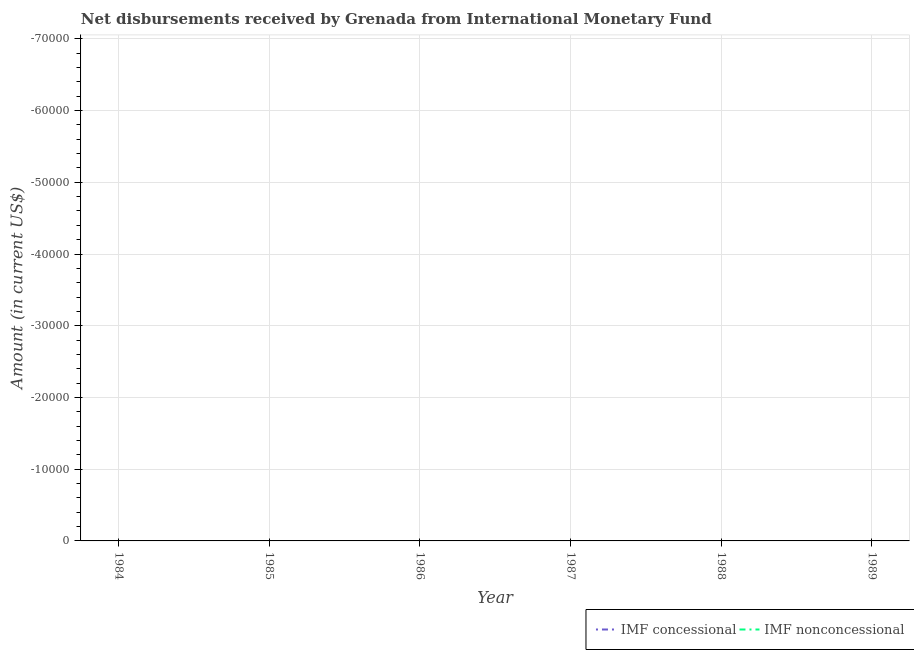How many different coloured lines are there?
Provide a succinct answer. 0. What is the total net non concessional disbursements from imf in the graph?
Make the answer very short. 0. Is the net non concessional disbursements from imf strictly greater than the net concessional disbursements from imf over the years?
Make the answer very short. No. Is the net concessional disbursements from imf strictly less than the net non concessional disbursements from imf over the years?
Your answer should be very brief. No. Are the values on the major ticks of Y-axis written in scientific E-notation?
Give a very brief answer. No. Does the graph contain grids?
Your response must be concise. Yes. How many legend labels are there?
Offer a very short reply. 2. What is the title of the graph?
Make the answer very short. Net disbursements received by Grenada from International Monetary Fund. Does "DAC donors" appear as one of the legend labels in the graph?
Your response must be concise. No. What is the label or title of the X-axis?
Give a very brief answer. Year. What is the Amount (in current US$) of IMF nonconcessional in 1985?
Your response must be concise. 0. What is the Amount (in current US$) of IMF concessional in 1986?
Your answer should be very brief. 0. What is the Amount (in current US$) in IMF nonconcessional in 1986?
Make the answer very short. 0. What is the Amount (in current US$) in IMF concessional in 1987?
Provide a succinct answer. 0. What is the Amount (in current US$) of IMF nonconcessional in 1987?
Your answer should be compact. 0. What is the Amount (in current US$) of IMF concessional in 1988?
Offer a very short reply. 0. What is the Amount (in current US$) in IMF nonconcessional in 1988?
Keep it short and to the point. 0. What is the average Amount (in current US$) in IMF concessional per year?
Make the answer very short. 0. 